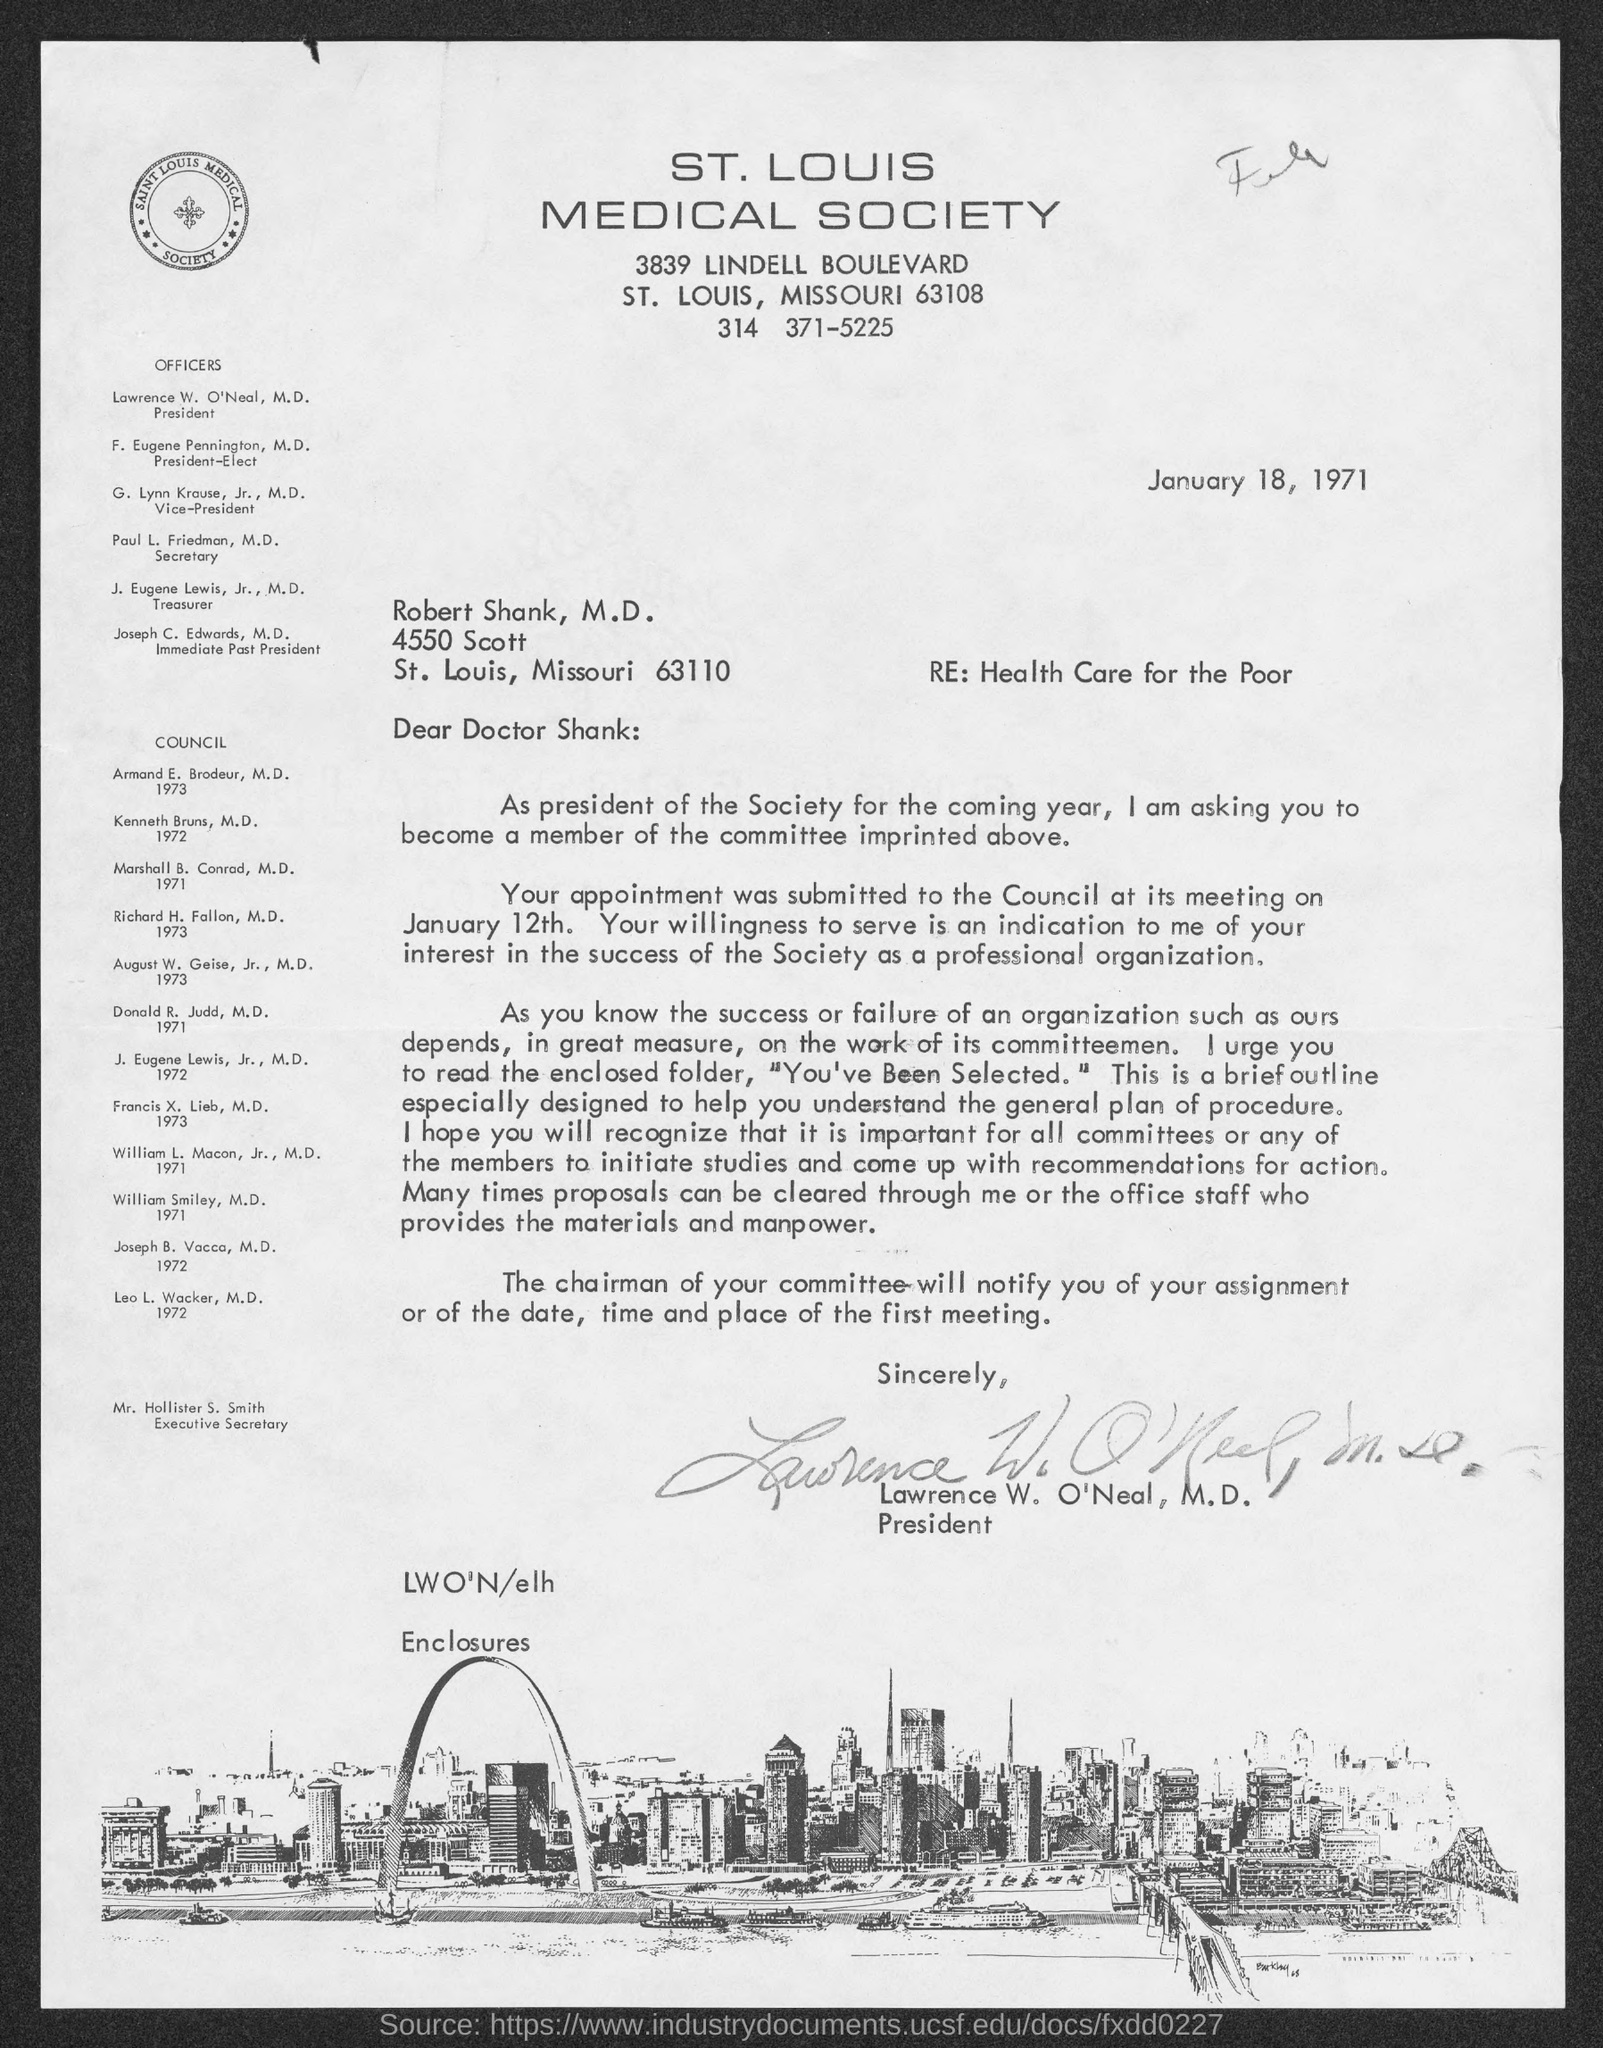Identify some key points in this picture. The President is Lawrence W. O'Neal. Mr. Hollister S. Smith holds the designation of Executive Secretary. The letter is addressed to Robert Shank, M.D. The letter was dated January 18, 1971. Paul L. Friedman, M.D., is the secretary. 